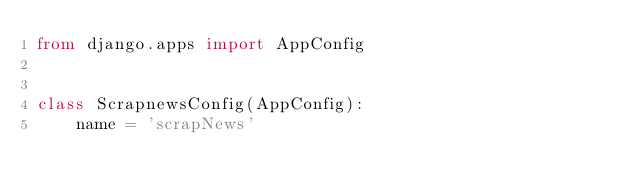<code> <loc_0><loc_0><loc_500><loc_500><_Python_>from django.apps import AppConfig


class ScrapnewsConfig(AppConfig):
    name = 'scrapNews'
</code> 